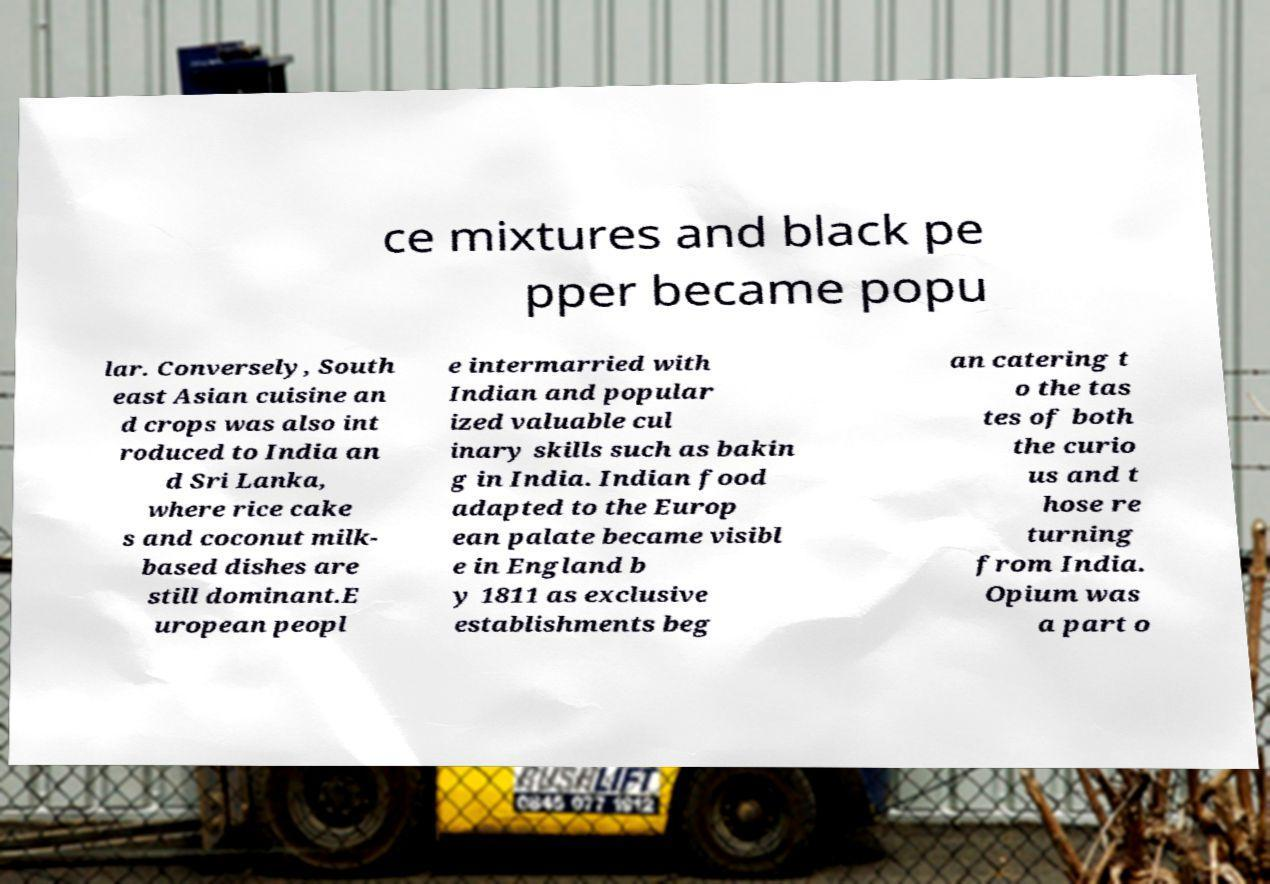For documentation purposes, I need the text within this image transcribed. Could you provide that? ce mixtures and black pe pper became popu lar. Conversely, South east Asian cuisine an d crops was also int roduced to India an d Sri Lanka, where rice cake s and coconut milk- based dishes are still dominant.E uropean peopl e intermarried with Indian and popular ized valuable cul inary skills such as bakin g in India. Indian food adapted to the Europ ean palate became visibl e in England b y 1811 as exclusive establishments beg an catering t o the tas tes of both the curio us and t hose re turning from India. Opium was a part o 